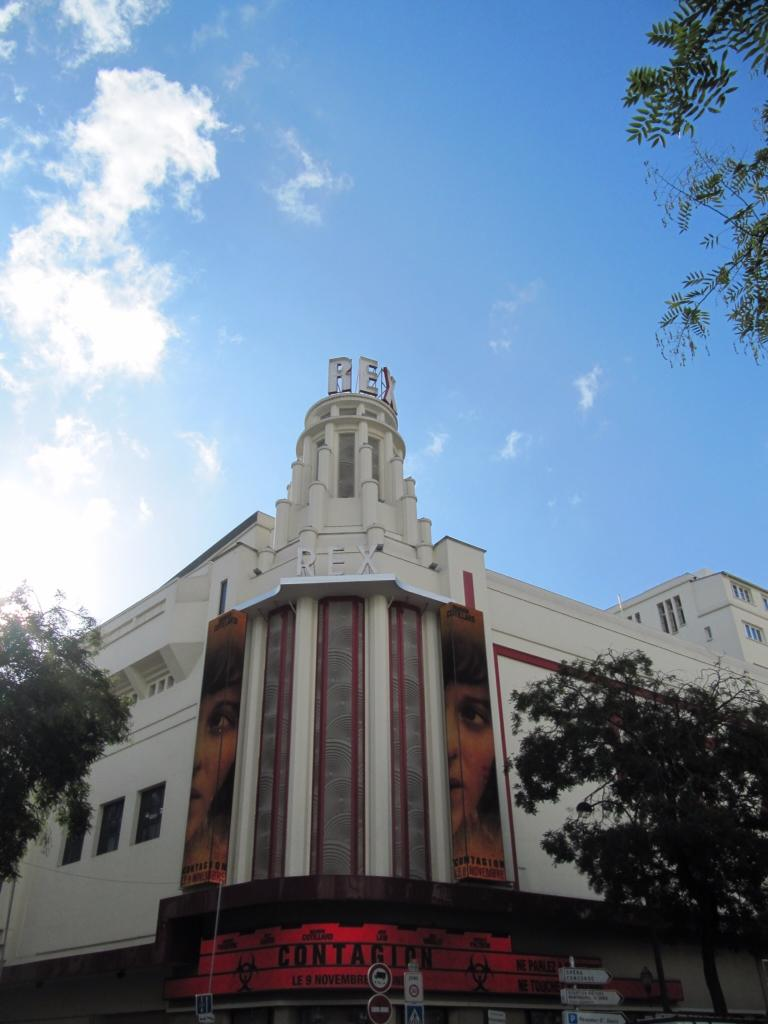<image>
Render a clear and concise summary of the photo. White large theater showing an ad playing for Contagion. 